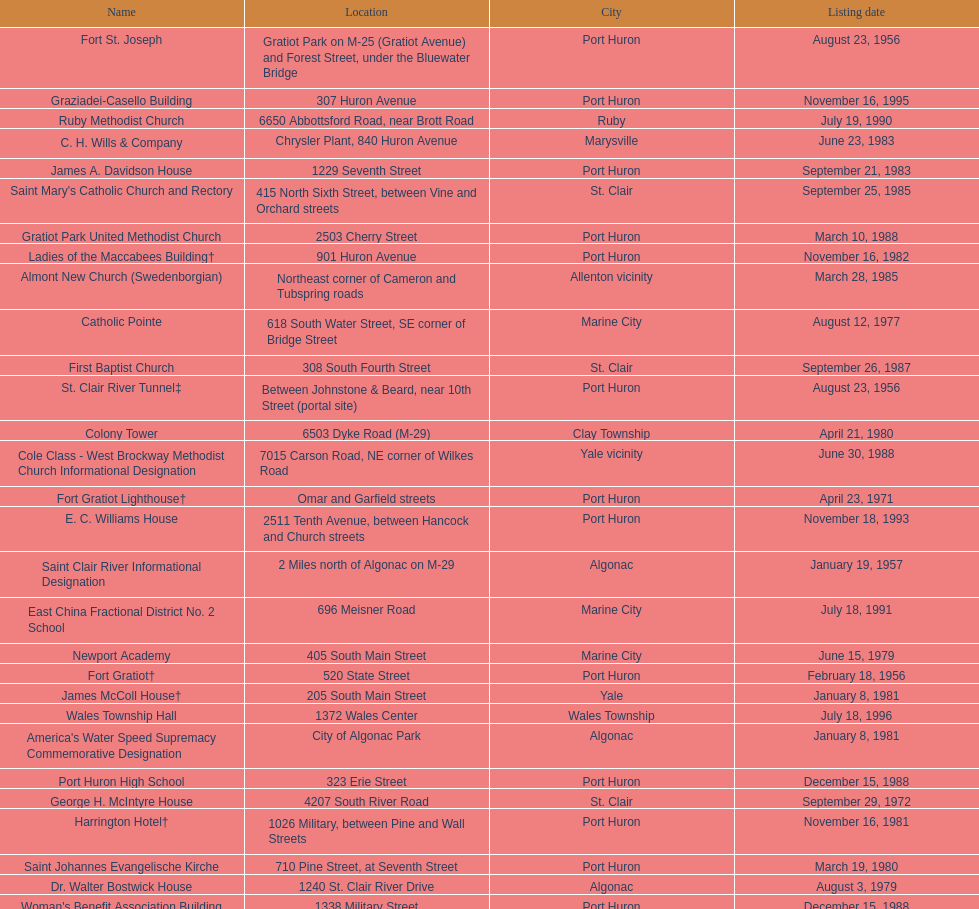What is the number of properties on the list that have been demolished? 2. 